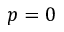<formula> <loc_0><loc_0><loc_500><loc_500>p = 0</formula> 